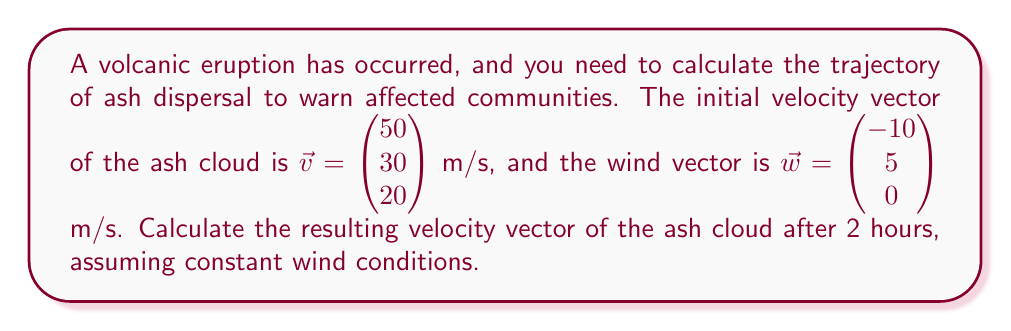What is the answer to this math problem? To solve this problem, we'll follow these steps:

1. Identify the given vectors:
   Initial velocity vector: $\vec{v} = \begin{pmatrix} 50 \\ 30 \\ 20 \end{pmatrix}$ m/s
   Wind vector: $\vec{w} = \begin{pmatrix} -10 \\ 5 \\ 0 \end{pmatrix}$ m/s

2. Calculate the combined velocity vector by adding the initial velocity and wind vectors:
   $$\vec{v}_{combined} = \vec{v} + \vec{w} = \begin{pmatrix} 50 \\ 30 \\ 20 \end{pmatrix} + \begin{pmatrix} -10 \\ 5 \\ 0 \end{pmatrix} = \begin{pmatrix} 40 \\ 35 \\ 20 \end{pmatrix}$$ m/s

3. Convert the time from hours to seconds:
   2 hours = 2 × 3600 seconds = 7200 seconds

4. Calculate the displacement vector by multiplying the combined velocity vector by time:
   $$\vec{d} = \vec{v}_{combined} \times t = \begin{pmatrix} 40 \\ 35 \\ 20 \end{pmatrix} \times 7200 = \begin{pmatrix} 288000 \\ 252000 \\ 144000 \end{pmatrix}$$ m

5. The resulting velocity vector after 2 hours remains the same as the combined velocity vector, assuming constant wind conditions:
   $$\vec{v}_{result} = \vec{v}_{combined} = \begin{pmatrix} 40 \\ 35 \\ 20 \end{pmatrix}$$ m/s
Answer: $\begin{pmatrix} 40 \\ 35 \\ 20 \end{pmatrix}$ m/s 